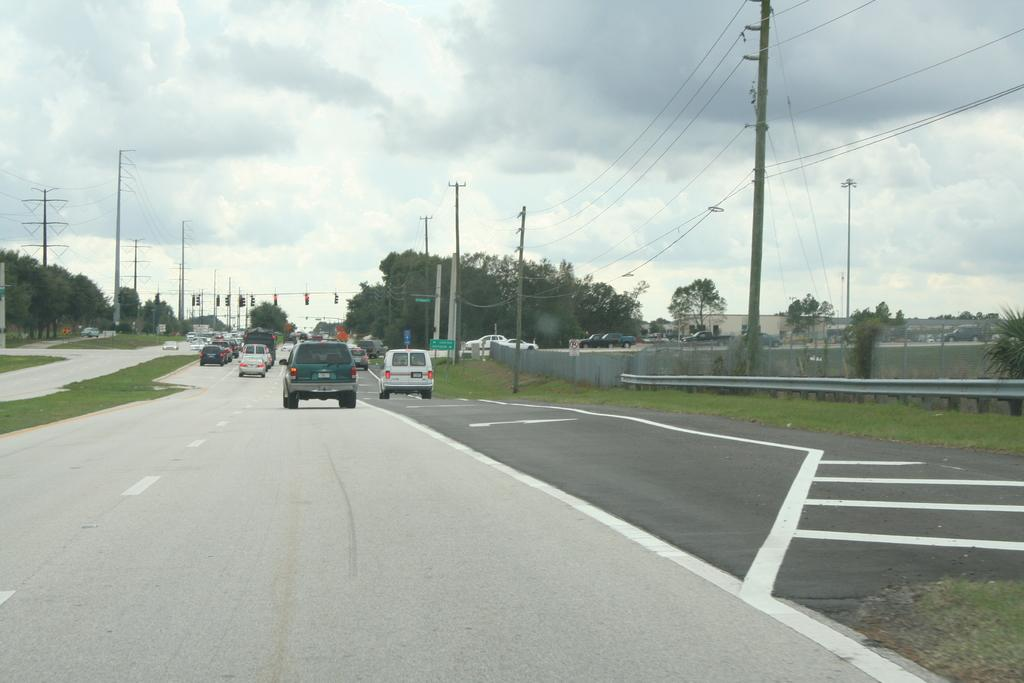What type of vehicles can be seen on the road in the image? There are cars on the road in the image. What natural elements are present in the image? There are trees and grass on the ground in the image. What man-made structures can be seen in the image? There are buildings and poles in the image. How would you describe the sky in the image? The sky is blue and cloudy in the image. What type of insurance is being sold at the cemetery in the image? There is no cemetery present in the image, and therefore no insurance being sold. Can you tell me how many pails are visible in the image? There are no pails visible in the image. 